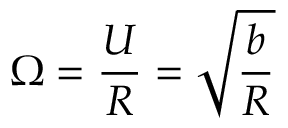Convert formula to latex. <formula><loc_0><loc_0><loc_500><loc_500>\Omega = \frac { U } { R } = \sqrt { \frac { b } { R } }</formula> 